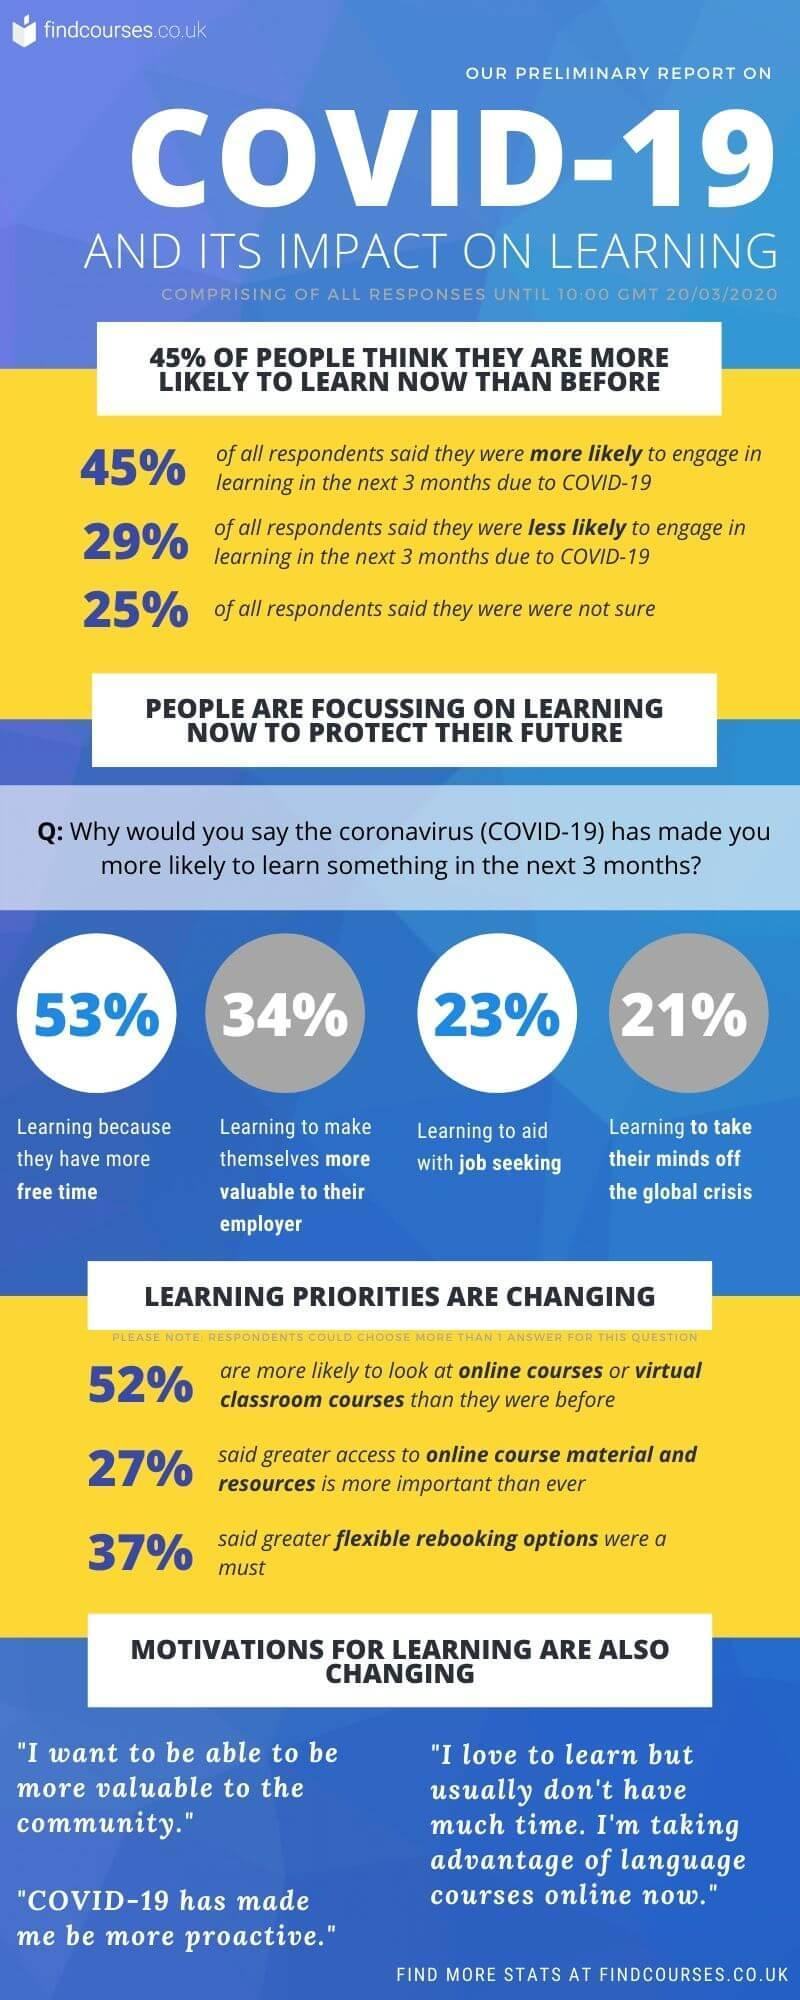What percentage of people are learning to make themselves more valuable to their employer?
Answer the question with a short phrase. 34% What percentage of people are learning to take their minds off the global crisis? 21% What percentage of people are learning because they have more free time? 53% What percentage of people are learning to aid with job seeking? 23% 